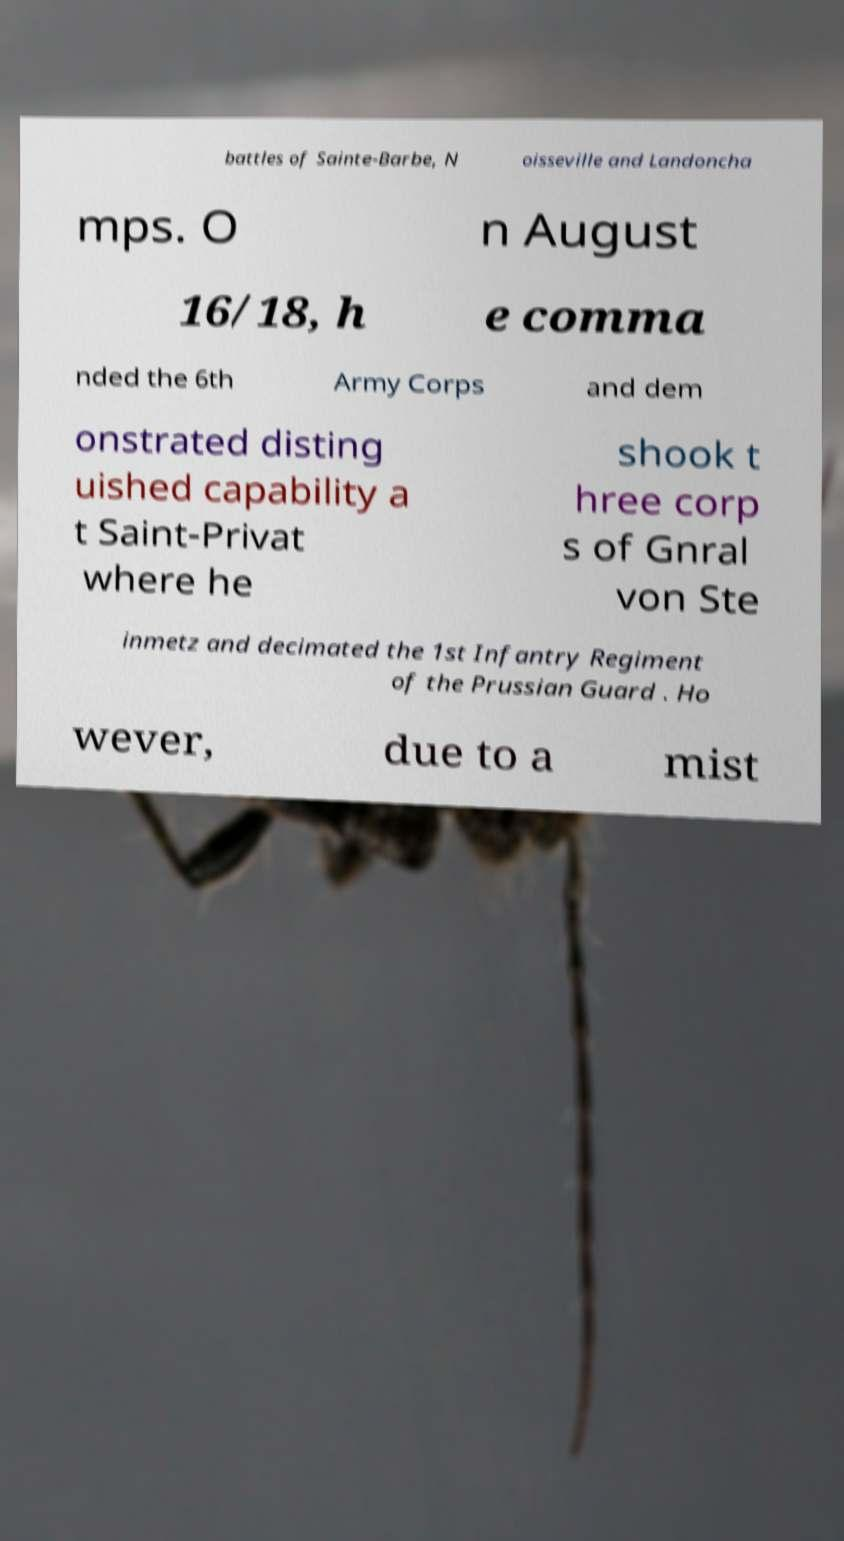Please read and relay the text visible in this image. What does it say? battles of Sainte-Barbe, N oisseville and Landoncha mps. O n August 16/18, h e comma nded the 6th Army Corps and dem onstrated disting uished capability a t Saint-Privat where he shook t hree corp s of Gnral von Ste inmetz and decimated the 1st Infantry Regiment of the Prussian Guard . Ho wever, due to a mist 